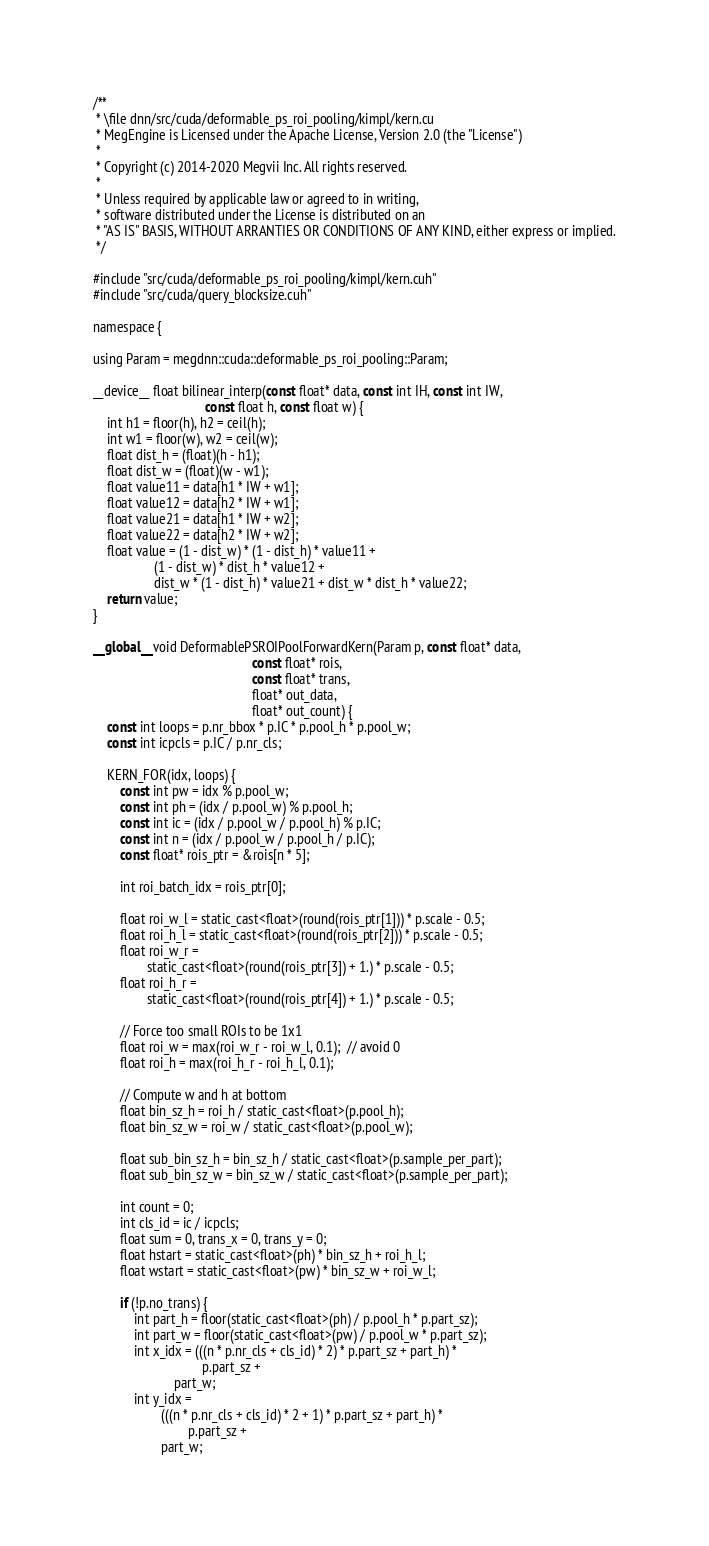Convert code to text. <code><loc_0><loc_0><loc_500><loc_500><_Cuda_>/**
 * \file dnn/src/cuda/deformable_ps_roi_pooling/kimpl/kern.cu
 * MegEngine is Licensed under the Apache License, Version 2.0 (the "License")
 *
 * Copyright (c) 2014-2020 Megvii Inc. All rights reserved.
 *
 * Unless required by applicable law or agreed to in writing,
 * software distributed under the License is distributed on an
 * "AS IS" BASIS, WITHOUT ARRANTIES OR CONDITIONS OF ANY KIND, either express or implied.
 */

#include "src/cuda/deformable_ps_roi_pooling/kimpl/kern.cuh"
#include "src/cuda/query_blocksize.cuh"

namespace {

using Param = megdnn::cuda::deformable_ps_roi_pooling::Param;

__device__ float bilinear_interp(const float* data, const int IH, const int IW,
                                 const float h, const float w) {
    int h1 = floor(h), h2 = ceil(h);
    int w1 = floor(w), w2 = ceil(w);
    float dist_h = (float)(h - h1);
    float dist_w = (float)(w - w1);
    float value11 = data[h1 * IW + w1];
    float value12 = data[h2 * IW + w1];
    float value21 = data[h1 * IW + w2];
    float value22 = data[h2 * IW + w2];
    float value = (1 - dist_w) * (1 - dist_h) * value11 +
                  (1 - dist_w) * dist_h * value12 +
                  dist_w * (1 - dist_h) * value21 + dist_w * dist_h * value22;
    return value;
}

__global__ void DeformablePSROIPoolForwardKern(Param p, const float* data,
                                               const float* rois,
                                               const float* trans,
                                               float* out_data,
                                               float* out_count) {
    const int loops = p.nr_bbox * p.IC * p.pool_h * p.pool_w;
    const int icpcls = p.IC / p.nr_cls;

    KERN_FOR(idx, loops) {
        const int pw = idx % p.pool_w;
        const int ph = (idx / p.pool_w) % p.pool_h;
        const int ic = (idx / p.pool_w / p.pool_h) % p.IC;
        const int n = (idx / p.pool_w / p.pool_h / p.IC);
        const float* rois_ptr = &rois[n * 5];

        int roi_batch_idx = rois_ptr[0];

        float roi_w_l = static_cast<float>(round(rois_ptr[1])) * p.scale - 0.5;
        float roi_h_l = static_cast<float>(round(rois_ptr[2])) * p.scale - 0.5;
        float roi_w_r =
                static_cast<float>(round(rois_ptr[3]) + 1.) * p.scale - 0.5;
        float roi_h_r =
                static_cast<float>(round(rois_ptr[4]) + 1.) * p.scale - 0.5;

        // Force too small ROIs to be 1x1
        float roi_w = max(roi_w_r - roi_w_l, 0.1);  // avoid 0
        float roi_h = max(roi_h_r - roi_h_l, 0.1);

        // Compute w and h at bottom
        float bin_sz_h = roi_h / static_cast<float>(p.pool_h);
        float bin_sz_w = roi_w / static_cast<float>(p.pool_w);

        float sub_bin_sz_h = bin_sz_h / static_cast<float>(p.sample_per_part);
        float sub_bin_sz_w = bin_sz_w / static_cast<float>(p.sample_per_part);

        int count = 0;
        int cls_id = ic / icpcls;
        float sum = 0, trans_x = 0, trans_y = 0;
        float hstart = static_cast<float>(ph) * bin_sz_h + roi_h_l;
        float wstart = static_cast<float>(pw) * bin_sz_w + roi_w_l;

        if (!p.no_trans) {
            int part_h = floor(static_cast<float>(ph) / p.pool_h * p.part_sz);
            int part_w = floor(static_cast<float>(pw) / p.pool_w * p.part_sz);
            int x_idx = (((n * p.nr_cls + cls_id) * 2) * p.part_sz + part_h) *
                                p.part_sz +
                        part_w;
            int y_idx =
                    (((n * p.nr_cls + cls_id) * 2 + 1) * p.part_sz + part_h) *
                            p.part_sz +
                    part_w;</code> 